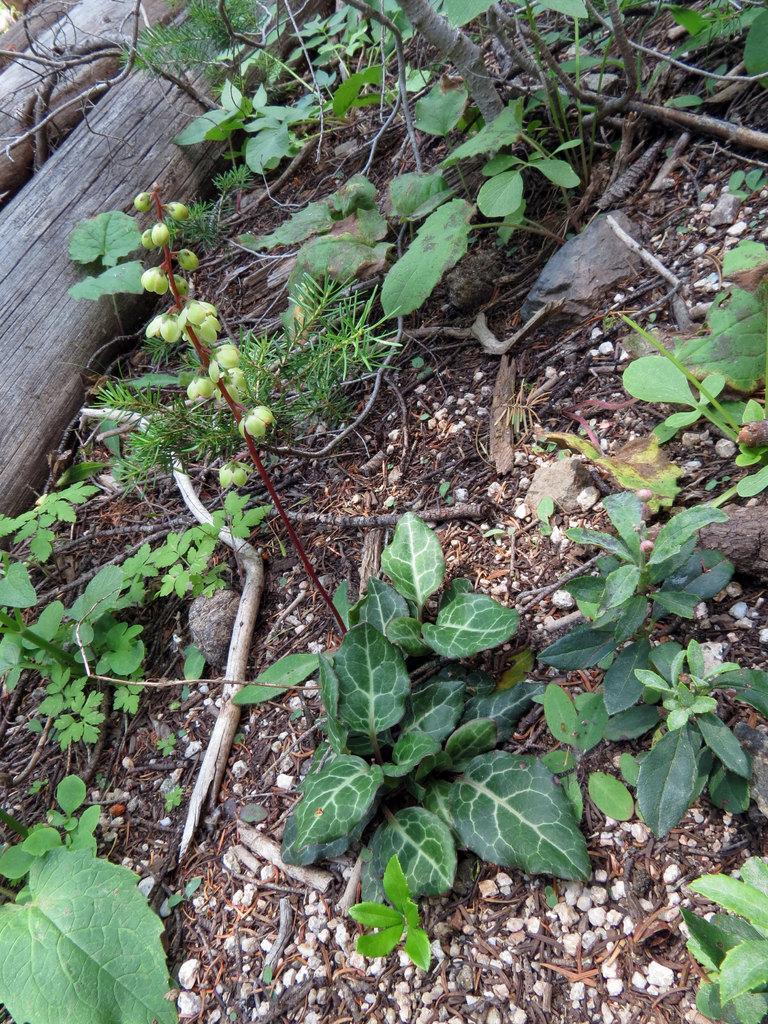Can you describe this image briefly? This image is taken outdoors. At the bottom of the image there is a ground with a few pebbles and plants with green leaves. At the top left of the image there is a bark on the ground. 